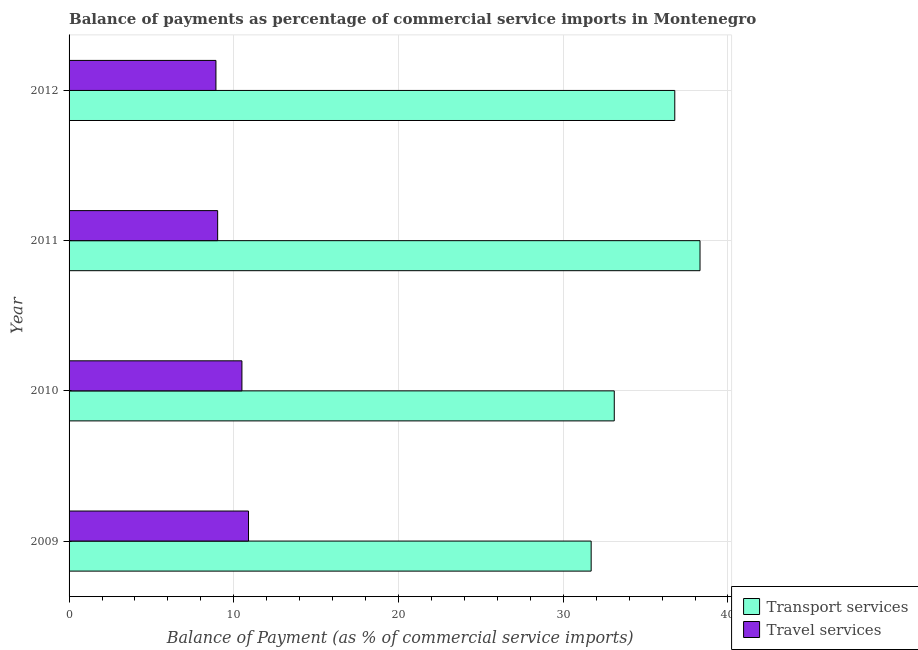How many different coloured bars are there?
Your answer should be very brief. 2. How many bars are there on the 2nd tick from the top?
Offer a terse response. 2. What is the balance of payments of transport services in 2012?
Ensure brevity in your answer.  36.77. Across all years, what is the maximum balance of payments of transport services?
Your response must be concise. 38.3. Across all years, what is the minimum balance of payments of travel services?
Offer a very short reply. 8.92. In which year was the balance of payments of transport services minimum?
Provide a succinct answer. 2009. What is the total balance of payments of transport services in the graph?
Your answer should be very brief. 139.86. What is the difference between the balance of payments of transport services in 2010 and that in 2012?
Ensure brevity in your answer.  -3.67. What is the difference between the balance of payments of travel services in 2011 and the balance of payments of transport services in 2012?
Provide a short and direct response. -27.75. What is the average balance of payments of transport services per year?
Your answer should be very brief. 34.97. In the year 2010, what is the difference between the balance of payments of transport services and balance of payments of travel services?
Your response must be concise. 22.6. What is the ratio of the balance of payments of transport services in 2011 to that in 2012?
Provide a succinct answer. 1.04. Is the balance of payments of transport services in 2011 less than that in 2012?
Keep it short and to the point. No. Is the difference between the balance of payments of transport services in 2009 and 2012 greater than the difference between the balance of payments of travel services in 2009 and 2012?
Offer a terse response. No. What is the difference between the highest and the lowest balance of payments of travel services?
Your answer should be very brief. 1.98. In how many years, is the balance of payments of travel services greater than the average balance of payments of travel services taken over all years?
Your answer should be very brief. 2. What does the 1st bar from the top in 2009 represents?
Your answer should be compact. Travel services. What does the 1st bar from the bottom in 2010 represents?
Your answer should be very brief. Transport services. How many bars are there?
Offer a very short reply. 8. Where does the legend appear in the graph?
Your answer should be very brief. Bottom right. How many legend labels are there?
Give a very brief answer. 2. How are the legend labels stacked?
Ensure brevity in your answer.  Vertical. What is the title of the graph?
Offer a terse response. Balance of payments as percentage of commercial service imports in Montenegro. Does "Short-term debt" appear as one of the legend labels in the graph?
Provide a short and direct response. No. What is the label or title of the X-axis?
Your answer should be compact. Balance of Payment (as % of commercial service imports). What is the Balance of Payment (as % of commercial service imports) in Transport services in 2009?
Offer a terse response. 31.69. What is the Balance of Payment (as % of commercial service imports) in Travel services in 2009?
Provide a short and direct response. 10.89. What is the Balance of Payment (as % of commercial service imports) of Transport services in 2010?
Your response must be concise. 33.1. What is the Balance of Payment (as % of commercial service imports) in Travel services in 2010?
Keep it short and to the point. 10.49. What is the Balance of Payment (as % of commercial service imports) of Transport services in 2011?
Give a very brief answer. 38.3. What is the Balance of Payment (as % of commercial service imports) in Travel services in 2011?
Give a very brief answer. 9.02. What is the Balance of Payment (as % of commercial service imports) of Transport services in 2012?
Offer a terse response. 36.77. What is the Balance of Payment (as % of commercial service imports) in Travel services in 2012?
Your answer should be compact. 8.92. Across all years, what is the maximum Balance of Payment (as % of commercial service imports) in Transport services?
Offer a very short reply. 38.3. Across all years, what is the maximum Balance of Payment (as % of commercial service imports) in Travel services?
Your response must be concise. 10.89. Across all years, what is the minimum Balance of Payment (as % of commercial service imports) of Transport services?
Give a very brief answer. 31.69. Across all years, what is the minimum Balance of Payment (as % of commercial service imports) of Travel services?
Your answer should be compact. 8.92. What is the total Balance of Payment (as % of commercial service imports) in Transport services in the graph?
Keep it short and to the point. 139.86. What is the total Balance of Payment (as % of commercial service imports) of Travel services in the graph?
Keep it short and to the point. 39.32. What is the difference between the Balance of Payment (as % of commercial service imports) of Transport services in 2009 and that in 2010?
Keep it short and to the point. -1.4. What is the difference between the Balance of Payment (as % of commercial service imports) of Travel services in 2009 and that in 2010?
Your response must be concise. 0.4. What is the difference between the Balance of Payment (as % of commercial service imports) of Transport services in 2009 and that in 2011?
Your response must be concise. -6.61. What is the difference between the Balance of Payment (as % of commercial service imports) in Travel services in 2009 and that in 2011?
Your answer should be very brief. 1.87. What is the difference between the Balance of Payment (as % of commercial service imports) of Transport services in 2009 and that in 2012?
Provide a succinct answer. -5.08. What is the difference between the Balance of Payment (as % of commercial service imports) of Travel services in 2009 and that in 2012?
Ensure brevity in your answer.  1.98. What is the difference between the Balance of Payment (as % of commercial service imports) of Transport services in 2010 and that in 2011?
Your answer should be compact. -5.21. What is the difference between the Balance of Payment (as % of commercial service imports) in Travel services in 2010 and that in 2011?
Provide a succinct answer. 1.47. What is the difference between the Balance of Payment (as % of commercial service imports) in Transport services in 2010 and that in 2012?
Provide a short and direct response. -3.67. What is the difference between the Balance of Payment (as % of commercial service imports) in Travel services in 2010 and that in 2012?
Provide a short and direct response. 1.58. What is the difference between the Balance of Payment (as % of commercial service imports) in Transport services in 2011 and that in 2012?
Ensure brevity in your answer.  1.53. What is the difference between the Balance of Payment (as % of commercial service imports) of Travel services in 2011 and that in 2012?
Your answer should be very brief. 0.1. What is the difference between the Balance of Payment (as % of commercial service imports) in Transport services in 2009 and the Balance of Payment (as % of commercial service imports) in Travel services in 2010?
Your answer should be very brief. 21.2. What is the difference between the Balance of Payment (as % of commercial service imports) of Transport services in 2009 and the Balance of Payment (as % of commercial service imports) of Travel services in 2011?
Offer a terse response. 22.67. What is the difference between the Balance of Payment (as % of commercial service imports) in Transport services in 2009 and the Balance of Payment (as % of commercial service imports) in Travel services in 2012?
Your response must be concise. 22.78. What is the difference between the Balance of Payment (as % of commercial service imports) of Transport services in 2010 and the Balance of Payment (as % of commercial service imports) of Travel services in 2011?
Offer a terse response. 24.08. What is the difference between the Balance of Payment (as % of commercial service imports) of Transport services in 2010 and the Balance of Payment (as % of commercial service imports) of Travel services in 2012?
Provide a short and direct response. 24.18. What is the difference between the Balance of Payment (as % of commercial service imports) in Transport services in 2011 and the Balance of Payment (as % of commercial service imports) in Travel services in 2012?
Ensure brevity in your answer.  29.39. What is the average Balance of Payment (as % of commercial service imports) in Transport services per year?
Provide a short and direct response. 34.97. What is the average Balance of Payment (as % of commercial service imports) in Travel services per year?
Make the answer very short. 9.83. In the year 2009, what is the difference between the Balance of Payment (as % of commercial service imports) in Transport services and Balance of Payment (as % of commercial service imports) in Travel services?
Your response must be concise. 20.8. In the year 2010, what is the difference between the Balance of Payment (as % of commercial service imports) in Transport services and Balance of Payment (as % of commercial service imports) in Travel services?
Your answer should be very brief. 22.6. In the year 2011, what is the difference between the Balance of Payment (as % of commercial service imports) in Transport services and Balance of Payment (as % of commercial service imports) in Travel services?
Offer a terse response. 29.28. In the year 2012, what is the difference between the Balance of Payment (as % of commercial service imports) of Transport services and Balance of Payment (as % of commercial service imports) of Travel services?
Offer a terse response. 27.85. What is the ratio of the Balance of Payment (as % of commercial service imports) in Transport services in 2009 to that in 2010?
Offer a terse response. 0.96. What is the ratio of the Balance of Payment (as % of commercial service imports) of Travel services in 2009 to that in 2010?
Your answer should be compact. 1.04. What is the ratio of the Balance of Payment (as % of commercial service imports) of Transport services in 2009 to that in 2011?
Your answer should be very brief. 0.83. What is the ratio of the Balance of Payment (as % of commercial service imports) in Travel services in 2009 to that in 2011?
Offer a very short reply. 1.21. What is the ratio of the Balance of Payment (as % of commercial service imports) in Transport services in 2009 to that in 2012?
Provide a succinct answer. 0.86. What is the ratio of the Balance of Payment (as % of commercial service imports) in Travel services in 2009 to that in 2012?
Give a very brief answer. 1.22. What is the ratio of the Balance of Payment (as % of commercial service imports) of Transport services in 2010 to that in 2011?
Ensure brevity in your answer.  0.86. What is the ratio of the Balance of Payment (as % of commercial service imports) in Travel services in 2010 to that in 2011?
Your answer should be compact. 1.16. What is the ratio of the Balance of Payment (as % of commercial service imports) of Transport services in 2010 to that in 2012?
Provide a short and direct response. 0.9. What is the ratio of the Balance of Payment (as % of commercial service imports) in Travel services in 2010 to that in 2012?
Keep it short and to the point. 1.18. What is the ratio of the Balance of Payment (as % of commercial service imports) of Transport services in 2011 to that in 2012?
Give a very brief answer. 1.04. What is the ratio of the Balance of Payment (as % of commercial service imports) of Travel services in 2011 to that in 2012?
Offer a very short reply. 1.01. What is the difference between the highest and the second highest Balance of Payment (as % of commercial service imports) of Transport services?
Your answer should be compact. 1.53. What is the difference between the highest and the second highest Balance of Payment (as % of commercial service imports) of Travel services?
Provide a succinct answer. 0.4. What is the difference between the highest and the lowest Balance of Payment (as % of commercial service imports) in Transport services?
Provide a short and direct response. 6.61. What is the difference between the highest and the lowest Balance of Payment (as % of commercial service imports) in Travel services?
Your answer should be very brief. 1.98. 